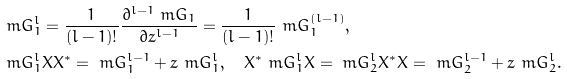<formula> <loc_0><loc_0><loc_500><loc_500>& \ m G _ { 1 } ^ { l } = \frac { 1 } { ( l - 1 ) ! } \frac { \partial ^ { l - 1 } \ m G _ { 1 } } { \partial z ^ { l - 1 } } = \frac { 1 } { ( l - 1 ) ! } \ m G _ { 1 } ^ { ( l - 1 ) } , \\ & \ m G _ { 1 } ^ { l } X X ^ { * } = \ m G _ { 1 } ^ { l - 1 } + z \ m G _ { 1 } ^ { l } , \quad X ^ { * } \ m G _ { 1 } ^ { l } X = \ m G _ { 2 } ^ { l } X ^ { * } X = \ m G _ { 2 } ^ { l - 1 } + z \ m G _ { 2 } ^ { l } .</formula> 